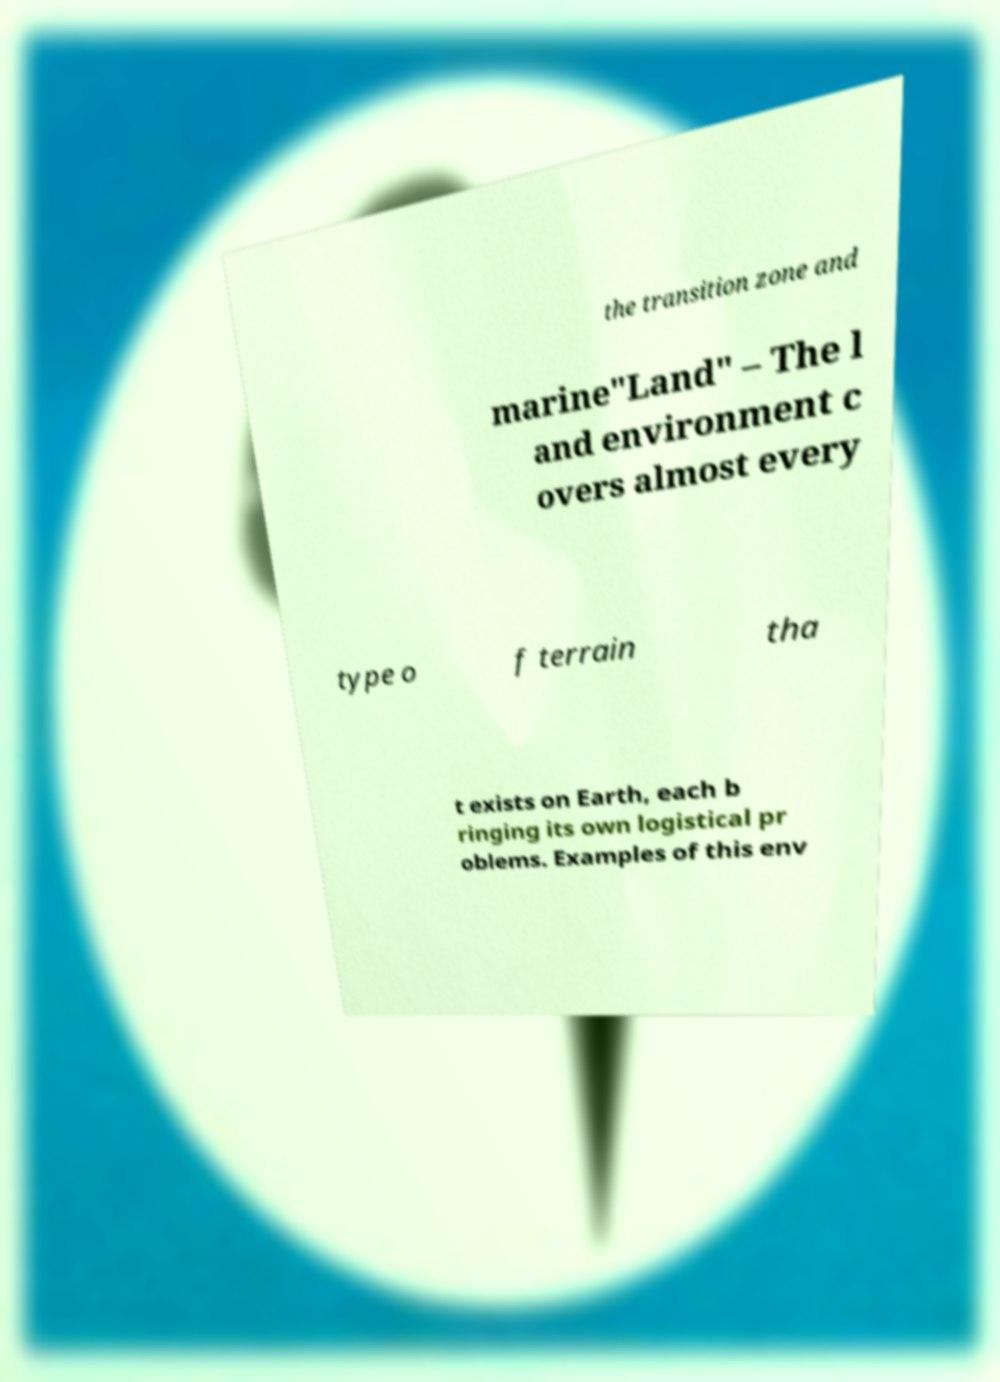There's text embedded in this image that I need extracted. Can you transcribe it verbatim? the transition zone and marine"Land" – The l and environment c overs almost every type o f terrain tha t exists on Earth, each b ringing its own logistical pr oblems. Examples of this env 